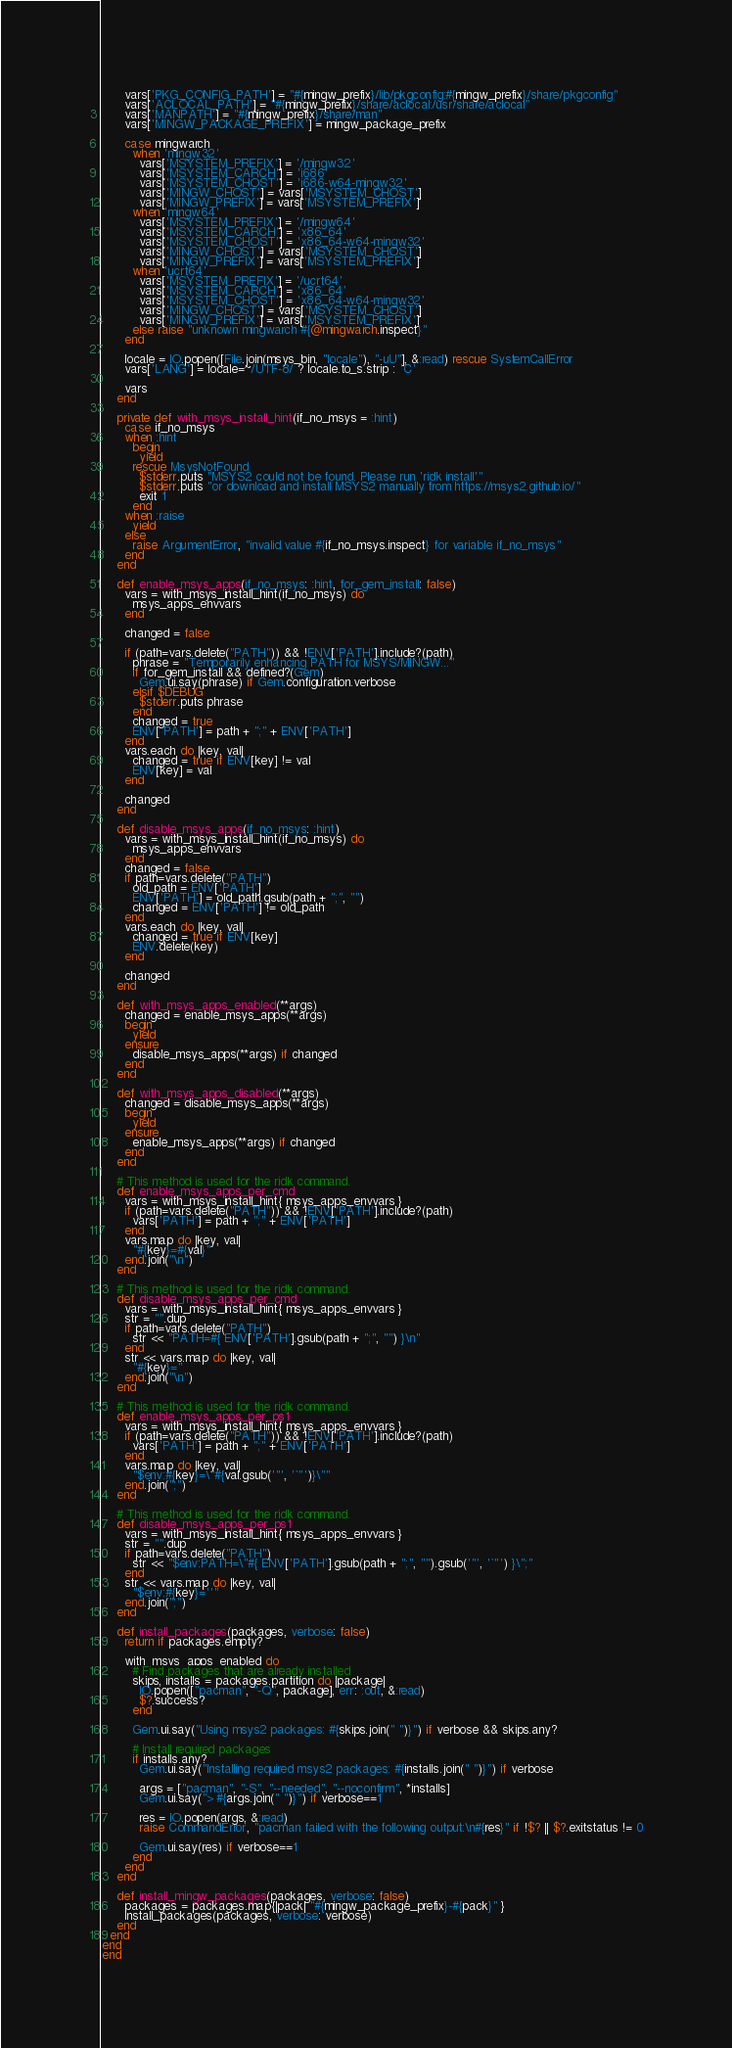<code> <loc_0><loc_0><loc_500><loc_500><_Ruby_>      vars['PKG_CONFIG_PATH'] = "#{mingw_prefix}/lib/pkgconfig:#{mingw_prefix}/share/pkgconfig"
      vars['ACLOCAL_PATH'] = "#{mingw_prefix}/share/aclocal:/usr/share/aclocal"
      vars['MANPATH'] = "#{mingw_prefix}/share/man"
      vars['MINGW_PACKAGE_PREFIX'] = mingw_package_prefix

      case mingwarch
        when 'mingw32'
          vars['MSYSTEM_PREFIX'] = '/mingw32'
          vars['MSYSTEM_CARCH'] = 'i686'
          vars['MSYSTEM_CHOST'] = 'i686-w64-mingw32'
          vars['MINGW_CHOST'] = vars['MSYSTEM_CHOST']
          vars['MINGW_PREFIX'] = vars['MSYSTEM_PREFIX']
        when 'mingw64'
          vars['MSYSTEM_PREFIX'] = '/mingw64'
          vars['MSYSTEM_CARCH'] = 'x86_64'
          vars['MSYSTEM_CHOST'] = 'x86_64-w64-mingw32'
          vars['MINGW_CHOST'] = vars['MSYSTEM_CHOST']
          vars['MINGW_PREFIX'] = vars['MSYSTEM_PREFIX']
        when 'ucrt64'
          vars['MSYSTEM_PREFIX'] = '/ucrt64'
          vars['MSYSTEM_CARCH'] = 'x86_64'
          vars['MSYSTEM_CHOST'] = 'x86_64-w64-mingw32'
          vars['MINGW_CHOST'] = vars['MSYSTEM_CHOST']
          vars['MINGW_PREFIX'] = vars['MSYSTEM_PREFIX']
        else raise "unknown mingwarch #{@mingwarch.inspect}"
      end

      locale = IO.popen([File.join(msys_bin, "locale"), "-uU"], &:read) rescue SystemCallError
      vars['LANG'] = locale=~/UTF-8/ ? locale.to_s.strip : 'C'

      vars
    end

    private def with_msys_install_hint(if_no_msys = :hint)
      case if_no_msys
      when :hint
        begin
          yield
        rescue MsysNotFound
          $stderr.puts "MSYS2 could not be found. Please run 'ridk install'"
          $stderr.puts "or download and install MSYS2 manually from https://msys2.github.io/"
          exit 1
        end
      when :raise
        yield
      else
        raise ArgumentError, "invalid value #{if_no_msys.inspect} for variable if_no_msys"
      end
    end

    def enable_msys_apps(if_no_msys: :hint, for_gem_install: false)
      vars = with_msys_install_hint(if_no_msys) do
        msys_apps_envvars
      end

      changed = false

      if (path=vars.delete("PATH")) && !ENV['PATH'].include?(path)
        phrase = "Temporarily enhancing PATH for MSYS/MINGW..."
        if for_gem_install && defined?(Gem)
          Gem.ui.say(phrase) if Gem.configuration.verbose
        elsif $DEBUG
          $stderr.puts phrase
        end
        changed = true
        ENV['PATH'] = path + ";" + ENV['PATH']
      end
      vars.each do |key, val|
        changed = true if ENV[key] != val
        ENV[key] = val
      end

      changed
    end

    def disable_msys_apps(if_no_msys: :hint)
      vars = with_msys_install_hint(if_no_msys) do
        msys_apps_envvars
      end
      changed = false
      if path=vars.delete("PATH")
        old_path = ENV['PATH']
        ENV['PATH'] = old_path.gsub(path + ";", "")
        changed = ENV['PATH'] != old_path
      end
      vars.each do |key, val|
        changed = true if ENV[key]
        ENV.delete(key)
      end

      changed
    end

    def with_msys_apps_enabled(**args)
      changed = enable_msys_apps(**args)
      begin
        yield
      ensure
        disable_msys_apps(**args) if changed
      end
    end

    def with_msys_apps_disabled(**args)
      changed = disable_msys_apps(**args)
      begin
        yield
      ensure
        enable_msys_apps(**args) if changed
      end
    end

    # This method is used for the ridk command.
    def enable_msys_apps_per_cmd
      vars = with_msys_install_hint{ msys_apps_envvars }
      if (path=vars.delete("PATH")) && !ENV['PATH'].include?(path)
        vars['PATH'] = path + ";" + ENV['PATH']
      end
      vars.map do |key, val|
        "#{key}=#{val}"
      end.join("\n")
    end

    # This method is used for the ridk command.
    def disable_msys_apps_per_cmd
      vars = with_msys_install_hint{ msys_apps_envvars }
      str = "".dup
      if path=vars.delete("PATH")
        str << "PATH=#{ ENV['PATH'].gsub(path + ";", "") }\n"
      end
      str << vars.map do |key, val|
        "#{key}="
      end.join("\n")
    end

    # This method is used for the ridk command.
    def enable_msys_apps_per_ps1
      vars = with_msys_install_hint{ msys_apps_envvars }
      if (path=vars.delete("PATH")) && !ENV['PATH'].include?(path)
        vars['PATH'] = path + ";" + ENV['PATH']
      end
      vars.map do |key, val|
        "$env:#{key}=\"#{val.gsub('"', '`"')}\""
      end.join(";")
    end

    # This method is used for the ridk command.
    def disable_msys_apps_per_ps1
      vars = with_msys_install_hint{ msys_apps_envvars }
      str = "".dup
      if path=vars.delete("PATH")
        str << "$env:PATH=\"#{ ENV['PATH'].gsub(path + ";", "").gsub('"', '`"') }\";"
      end
      str << vars.map do |key, val|
        "$env:#{key}=''"
      end.join(";")
    end

    def install_packages(packages, verbose: false)
      return if packages.empty?

      with_msys_apps_enabled do
        # Find packages that are already installed
        skips, installs = packages.partition do |package|
          IO.popen(["pacman", "-Q", package], err: :out, &:read)
          $?.success?
        end

        Gem.ui.say("Using msys2 packages: #{skips.join(" ")}") if verbose && skips.any?

        # Install required packages
        if installs.any?
          Gem.ui.say("Installing required msys2 packages: #{installs.join(" ")}") if verbose

          args = ["pacman", "-S", "--needed", "--noconfirm", *installs]
          Gem.ui.say("> #{args.join(" ")}") if verbose==1

          res = IO.popen(args, &:read)
          raise CommandError, "pacman failed with the following output:\n#{res}" if !$? || $?.exitstatus != 0

          Gem.ui.say(res) if verbose==1
        end
      end
    end

    def install_mingw_packages(packages, verbose: false)
      packages = packages.map{|pack| "#{mingw_package_prefix}-#{pack}" }
      install_packages(packages, verbose: verbose)
    end
  end
end
end
</code> 